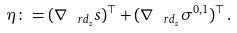Convert formula to latex. <formula><loc_0><loc_0><loc_500><loc_500>\eta \colon = ( \nabla _ { \ r d _ { z } } s ) ^ { \top } + ( \nabla _ { \ r d _ { z } } \sigma ^ { 0 , 1 } ) ^ { \top } \, .</formula> 